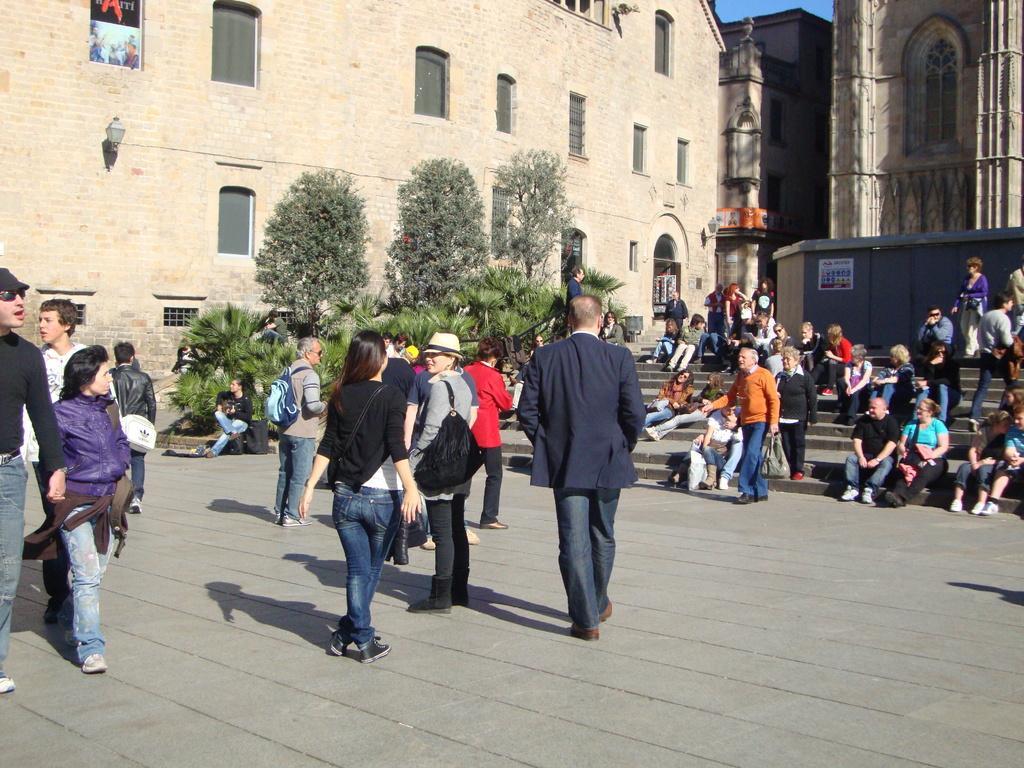In one or two sentences, can you explain what this image depicts? This image consists of many people walking and standing on the road. In the background, there are buildings along with windows. At the bottom, there are trees. To the right there are steps on which many people are sitting. 